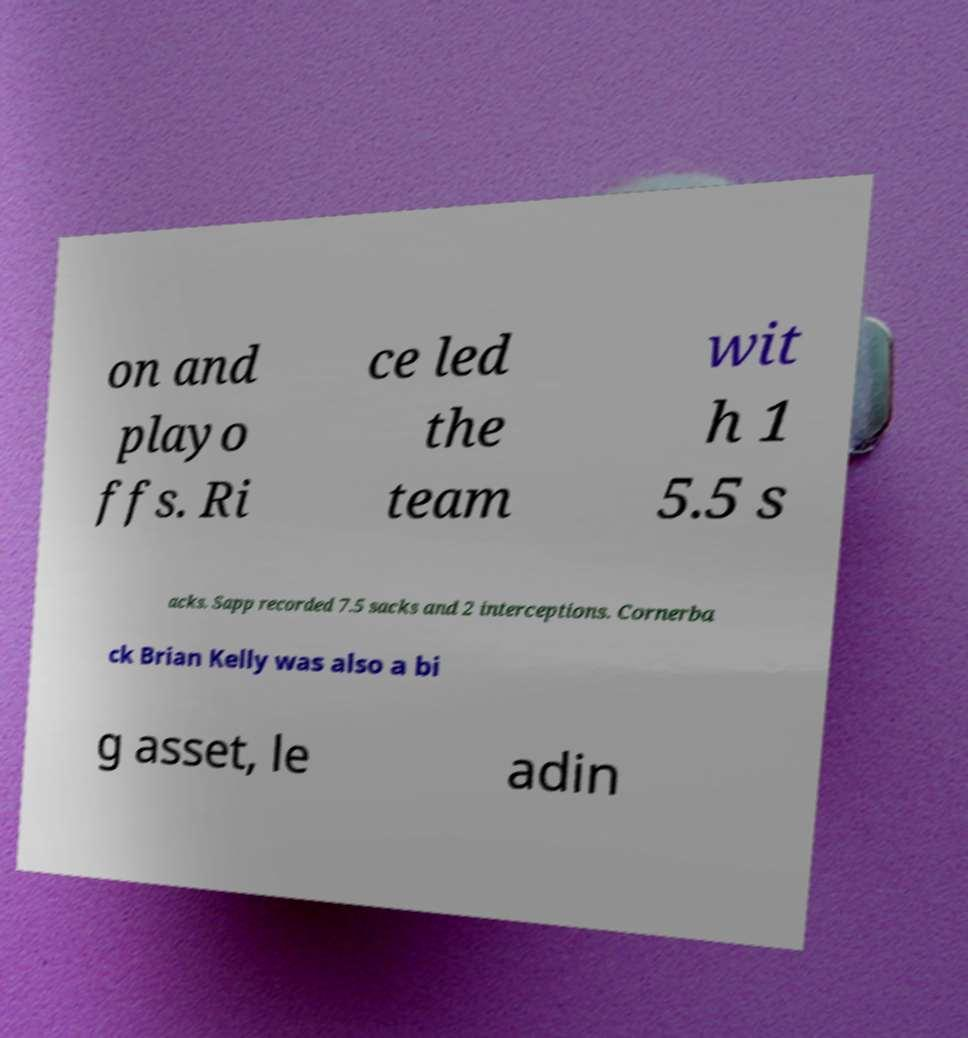There's text embedded in this image that I need extracted. Can you transcribe it verbatim? on and playo ffs. Ri ce led the team wit h 1 5.5 s acks. Sapp recorded 7.5 sacks and 2 interceptions. Cornerba ck Brian Kelly was also a bi g asset, le adin 